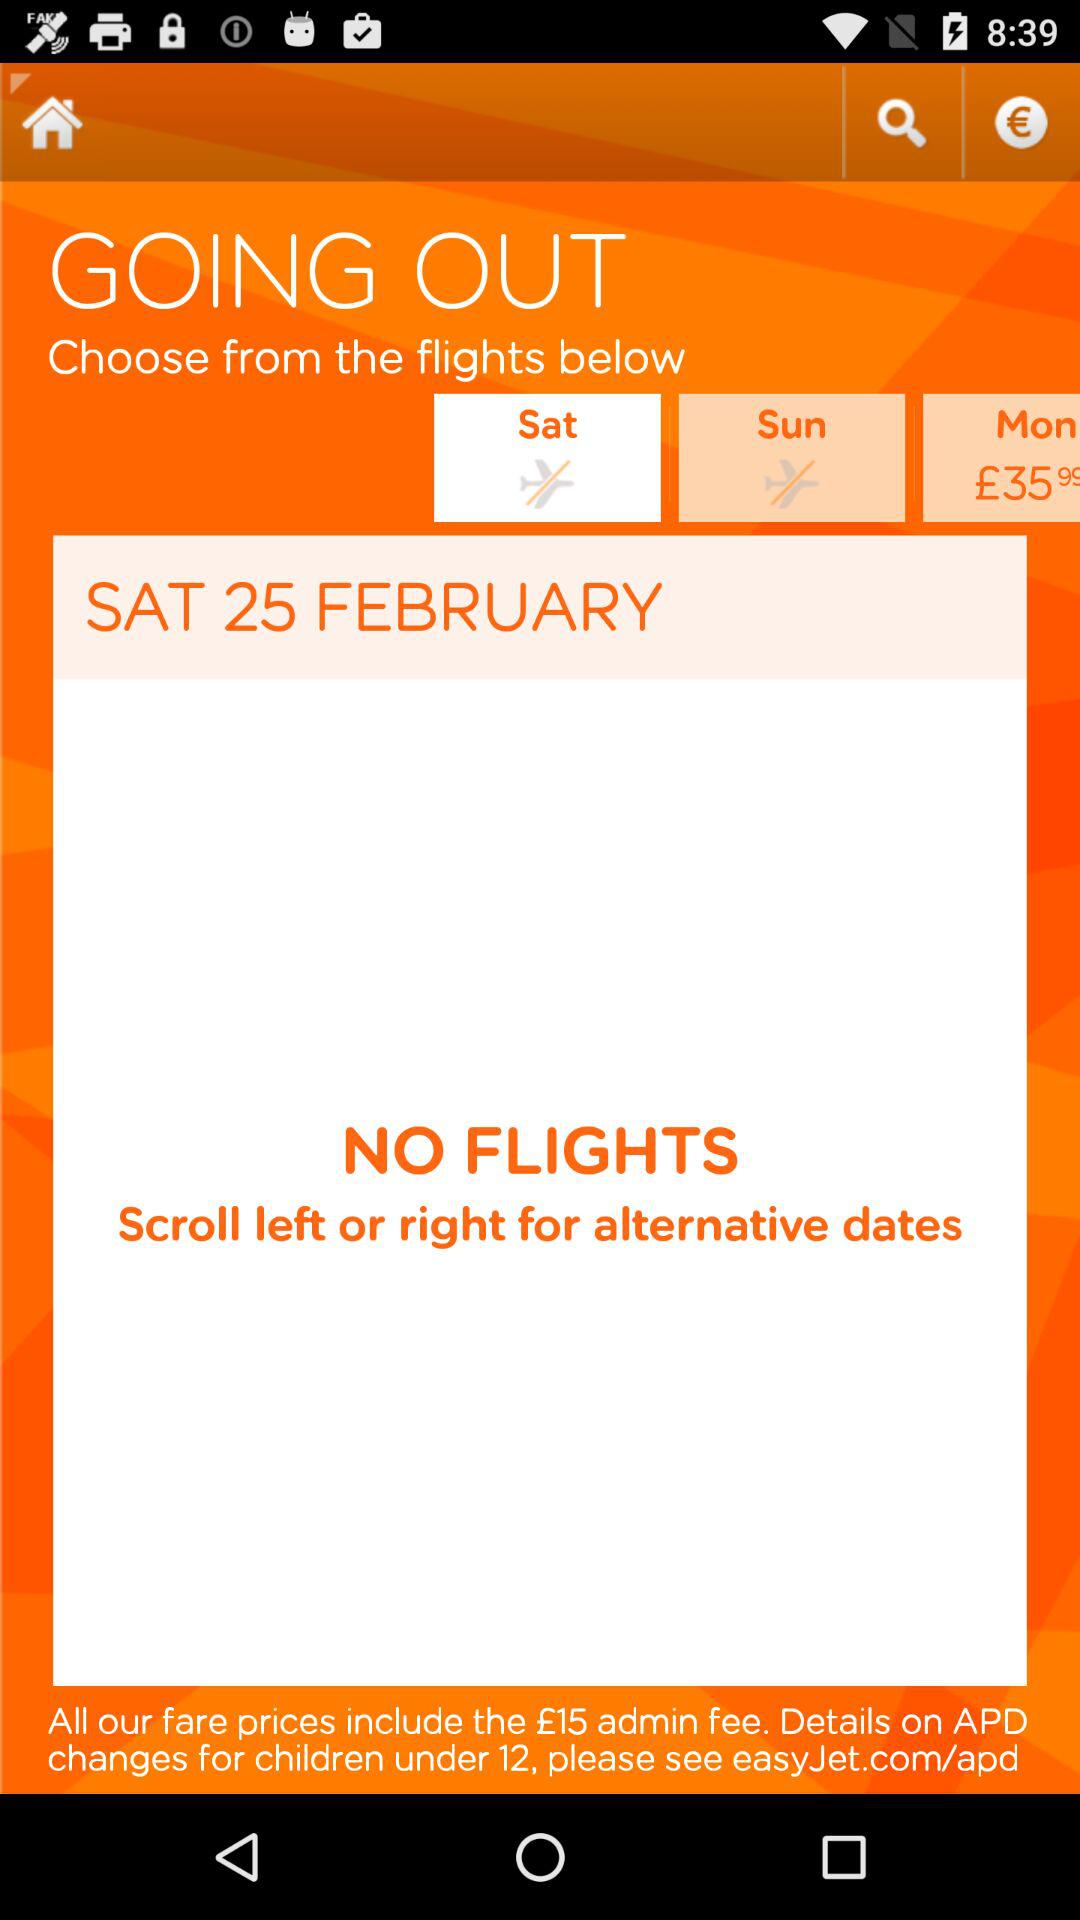What is the date? The date is Saturday, February 25. 